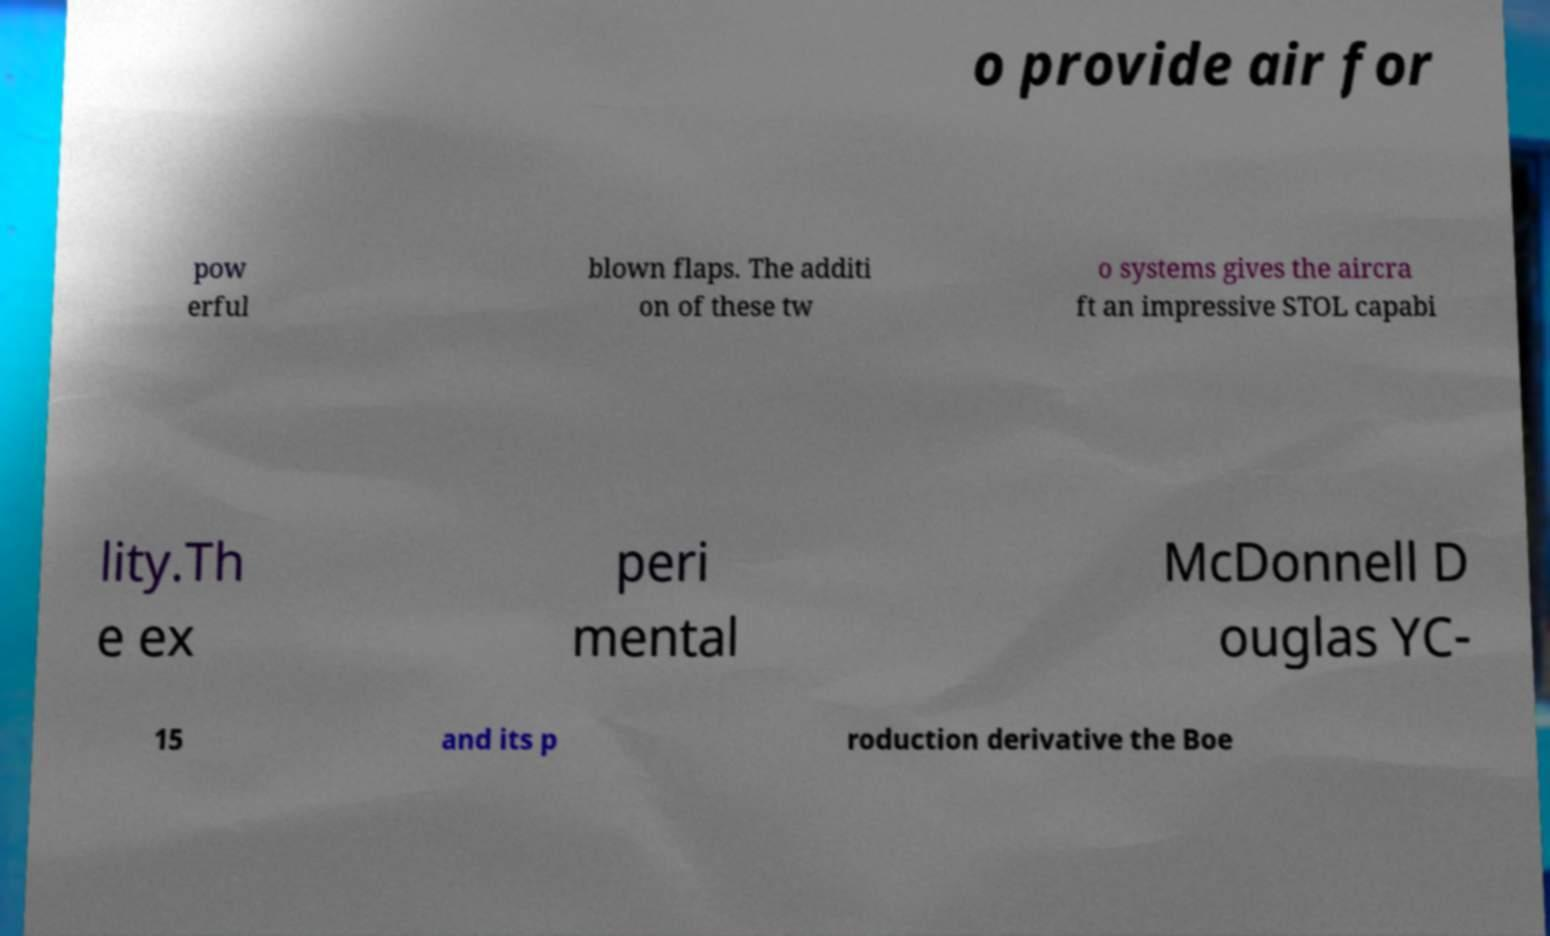Could you assist in decoding the text presented in this image and type it out clearly? o provide air for pow erful blown flaps. The additi on of these tw o systems gives the aircra ft an impressive STOL capabi lity.Th e ex peri mental McDonnell D ouglas YC- 15 and its p roduction derivative the Boe 